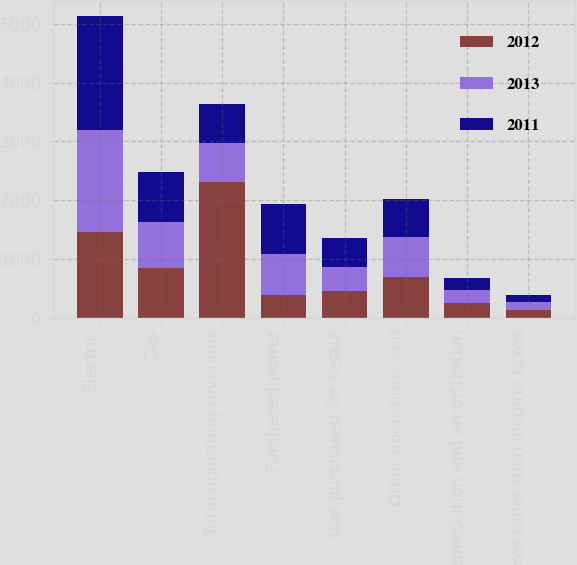<chart> <loc_0><loc_0><loc_500><loc_500><stacked_bar_chart><ecel><fcel>Electric<fcel>Gas<fcel>Total operating revenues<fcel>Purchased power<fcel>Gas purchased for resale<fcel>Other operations and<fcel>Depreciation and amortization<fcel>Taxes other than income taxes<nl><fcel>2012<fcel>1461<fcel>847<fcel>2311<fcel>380<fcel>448<fcel>693<fcel>243<fcel>132<nl><fcel>2013<fcel>1739<fcel>786<fcel>662<fcel>705<fcel>408<fcel>684<fcel>221<fcel>130<nl><fcel>2011<fcel>1940<fcel>846<fcel>662<fcel>853<fcel>492<fcel>640<fcel>215<fcel>129<nl></chart> 